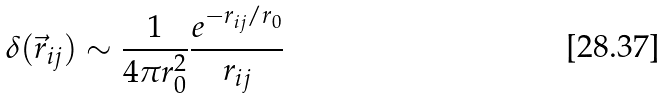Convert formula to latex. <formula><loc_0><loc_0><loc_500><loc_500>\delta ( \vec { r } _ { i j } ) \sim \frac { 1 } { 4 \pi r _ { 0 } ^ { 2 } } \frac { e ^ { - r _ { i j } / r _ { 0 } } } { r _ { i j } }</formula> 